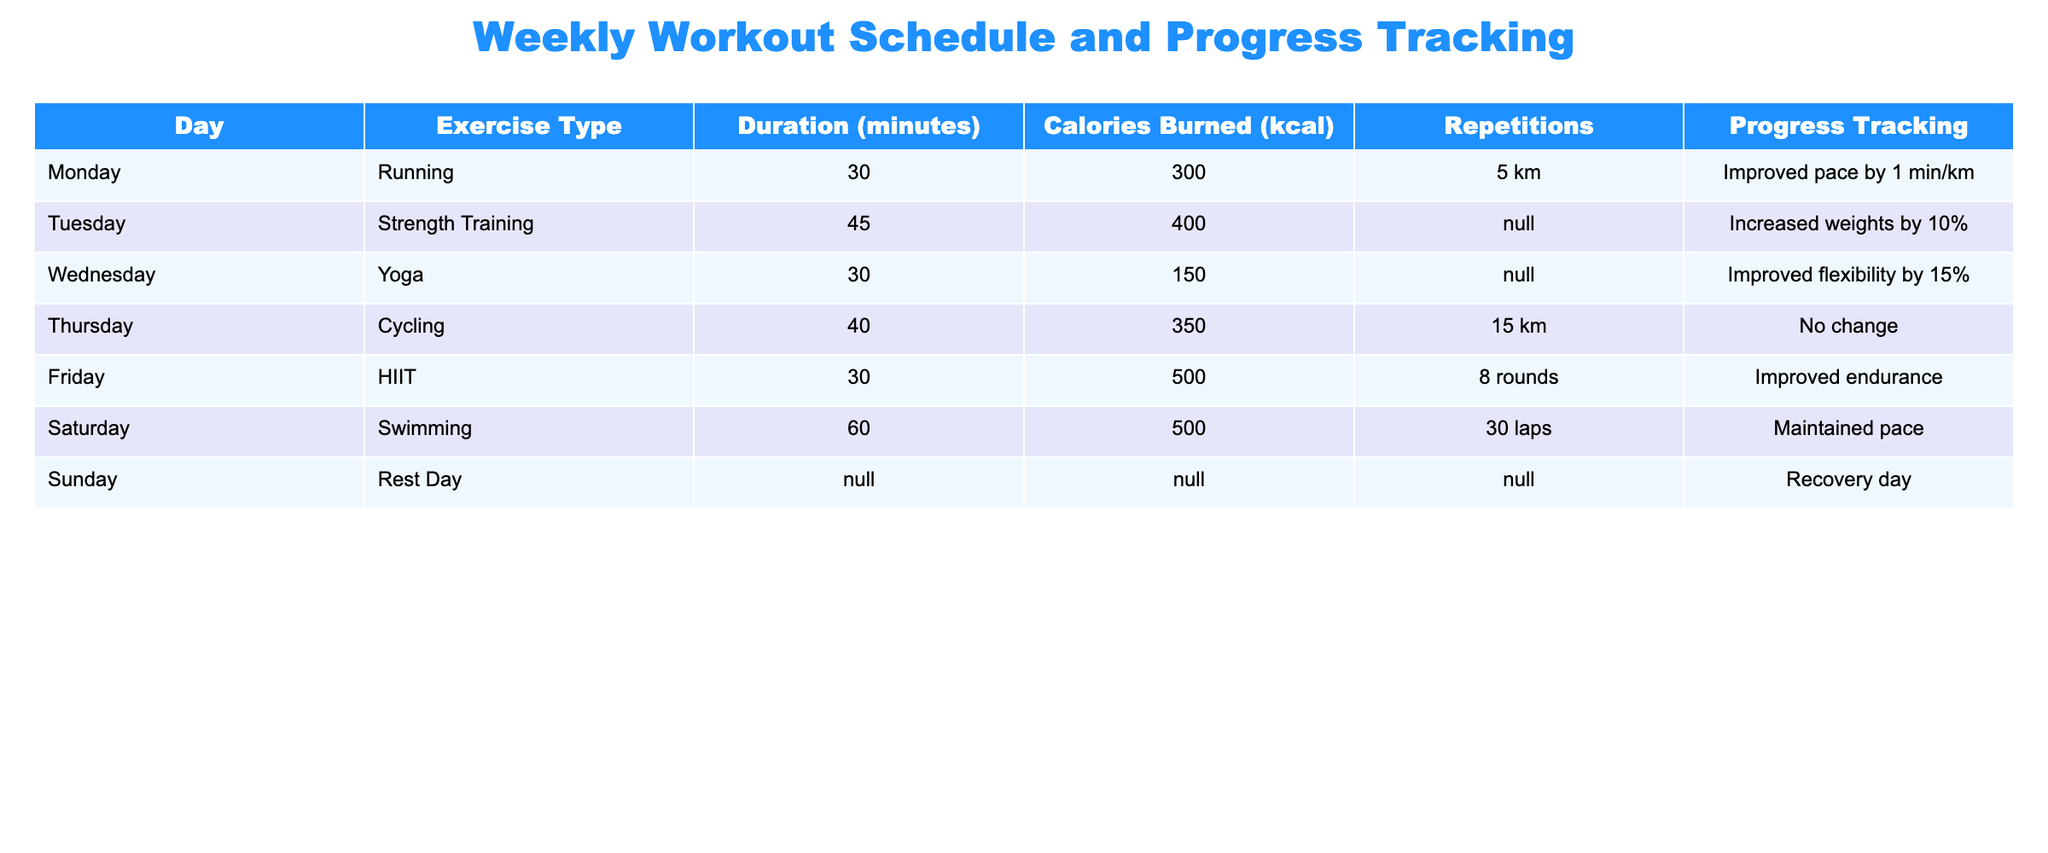What exercise did you do on Thursday? The table specifies the exercise type for each day. On Thursday, the exercise type listed is Cycling.
Answer: Cycling How many calories were burned on Monday? Referring to the table, the calories burned for Monday are indicated to be 300 kcal.
Answer: 300 kcal What was the total duration of all workouts for the week? The durations for each day need to be summed. Monday (30) + Tuesday (45) + Wednesday (30) + Thursday (40) + Friday (30) + Saturday (60) = 235 minutes.
Answer: 235 minutes Did you improve your flexibility on Wednesday? In the progress tracking for Wednesday, it states that flexibility improved by 15%, which confirms the improvement.
Answer: Yes What was the average calories burned per session throughout the week? To find the average, add all the calories burned during the week (300 + 400 + 150 + 350 + 500 + 500 + 0) = 2200 kcal and divide by the number of active days (6), resulting in 2200/6 = 366.67 kcal.
Answer: 366.67 kcal Was there any change recorded for cycling on Thursday? The progress tracking entry for Thursday states "No change", so there were no changes recorded for cycling.
Answer: No What day had the highest calories burned, and how many were burned? By examining the calories burned per day, Friday had the highest with 500 kcal burned during HIIT.
Answer: Friday, 500 kcal Which exercise had the longest duration, and how long was it? By comparing all the durations, Swimming has the longest duration at 60 minutes on Saturday.
Answer: Swimming, 60 minutes On which day did you rest, and what does it specify? The table indicates Sunday as the rest day with "Recovery day" noted in the progress tracking.
Answer: Sunday, Recovery day 